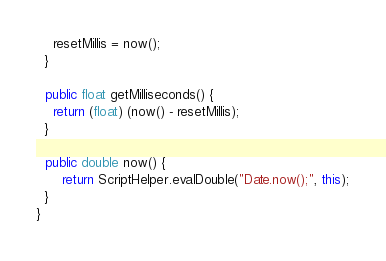Convert code to text. <code><loc_0><loc_0><loc_500><loc_500><_Java_>    resetMillis = now();
  }

  public float getMilliseconds() {
    return (float) (now() - resetMillis);
  }

  public double now() {
	  return ScriptHelper.evalDouble("Date.now();", this);
  }
}
</code> 